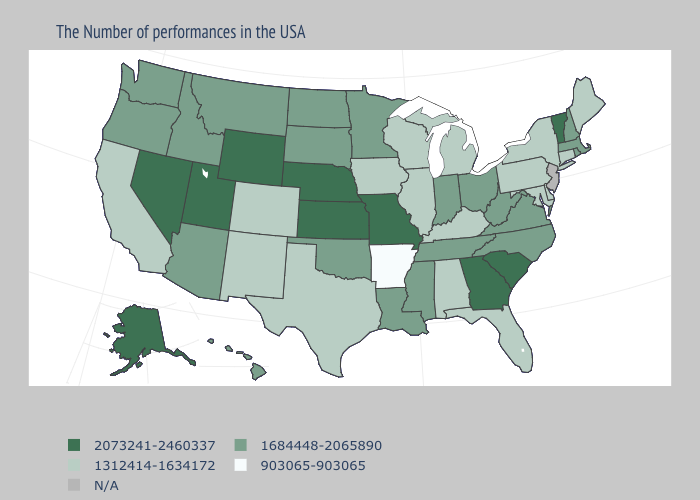Does the map have missing data?
Answer briefly. Yes. Name the states that have a value in the range N/A?
Give a very brief answer. New Jersey. Name the states that have a value in the range 1312414-1634172?
Short answer required. Maine, Connecticut, New York, Delaware, Maryland, Pennsylvania, Florida, Michigan, Kentucky, Alabama, Wisconsin, Illinois, Iowa, Texas, Colorado, New Mexico, California. Does Pennsylvania have the lowest value in the Northeast?
Be succinct. Yes. Does Kentucky have the highest value in the USA?
Write a very short answer. No. Name the states that have a value in the range N/A?
Give a very brief answer. New Jersey. Name the states that have a value in the range 903065-903065?
Be succinct. Arkansas. Name the states that have a value in the range 903065-903065?
Answer briefly. Arkansas. What is the value of Pennsylvania?
Answer briefly. 1312414-1634172. How many symbols are there in the legend?
Concise answer only. 5. Is the legend a continuous bar?
Short answer required. No. Name the states that have a value in the range 1684448-2065890?
Keep it brief. Massachusetts, Rhode Island, New Hampshire, Virginia, North Carolina, West Virginia, Ohio, Indiana, Tennessee, Mississippi, Louisiana, Minnesota, Oklahoma, South Dakota, North Dakota, Montana, Arizona, Idaho, Washington, Oregon, Hawaii. Name the states that have a value in the range 1312414-1634172?
Answer briefly. Maine, Connecticut, New York, Delaware, Maryland, Pennsylvania, Florida, Michigan, Kentucky, Alabama, Wisconsin, Illinois, Iowa, Texas, Colorado, New Mexico, California. Which states have the highest value in the USA?
Be succinct. Vermont, South Carolina, Georgia, Missouri, Kansas, Nebraska, Wyoming, Utah, Nevada, Alaska. Does the first symbol in the legend represent the smallest category?
Be succinct. No. 